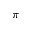Convert formula to latex. <formula><loc_0><loc_0><loc_500><loc_500>\pi</formula> 